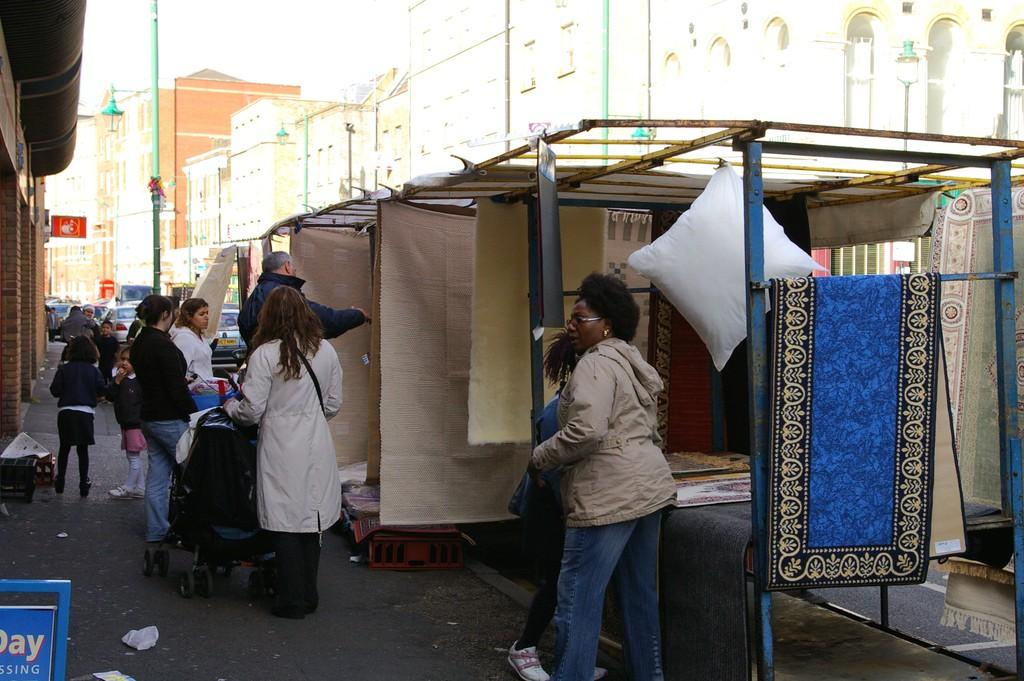What type of structures can be seen in the image? There are buildings in the image. What can be seen illuminating the area in the image? Street lights are visible in the image. What activity are people engaged in near a stall in the image? There are people near a stall in the image. What mode of transportation can be seen in the image? Vehicles are present in the image. What type of vegetable is being sold by the expert at the stall in the image? There is no vegetable or expert present at the stall in the image. What type of voyage is depicted in the image? There is no voyage depicted in the image; it features buildings, street lights, people, and vehicles. 